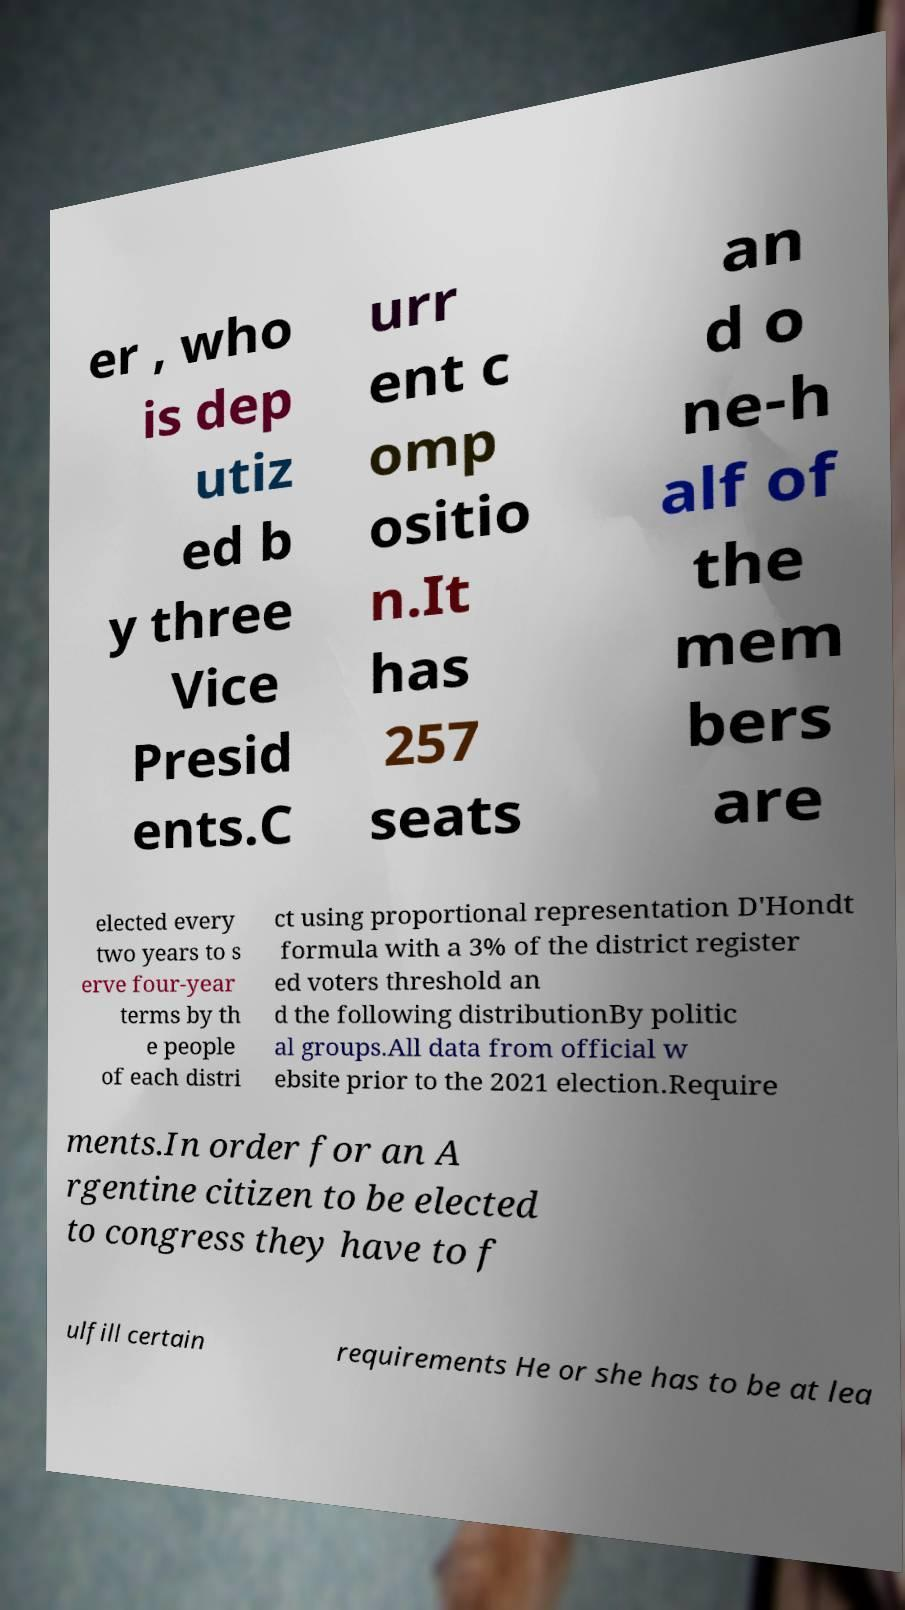Could you extract and type out the text from this image? er , who is dep utiz ed b y three Vice Presid ents.C urr ent c omp ositio n.It has 257 seats an d o ne-h alf of the mem bers are elected every two years to s erve four-year terms by th e people of each distri ct using proportional representation D'Hondt formula with a 3% of the district register ed voters threshold an d the following distributionBy politic al groups.All data from official w ebsite prior to the 2021 election.Require ments.In order for an A rgentine citizen to be elected to congress they have to f ulfill certain requirements He or she has to be at lea 